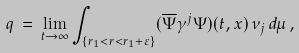Convert formula to latex. <formula><loc_0><loc_0><loc_500><loc_500>q \, = \, \lim _ { t \rightarrow \infty } \int _ { \{ r _ { 1 } < r < r _ { 1 } + \varepsilon \} } ( \overline { \Psi } \gamma ^ { j } \Psi ) ( t , x ) \, \nu _ { j } \, d \mu \, ,</formula> 